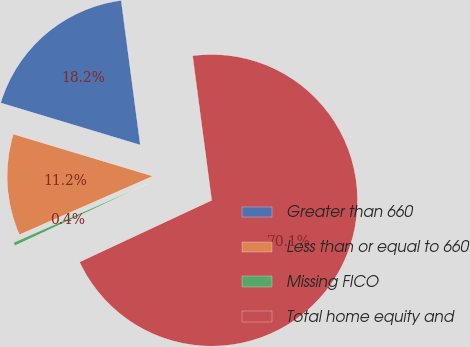Convert chart. <chart><loc_0><loc_0><loc_500><loc_500><pie_chart><fcel>Greater than 660<fcel>Less than or equal to 660<fcel>Missing FICO<fcel>Total home equity and<nl><fcel>18.25%<fcel>11.24%<fcel>0.37%<fcel>70.14%<nl></chart> 